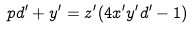<formula> <loc_0><loc_0><loc_500><loc_500>p d ^ { \prime } + y ^ { \prime } = z ^ { \prime } ( 4 x ^ { \prime } y ^ { \prime } d ^ { \prime } - 1 )</formula> 